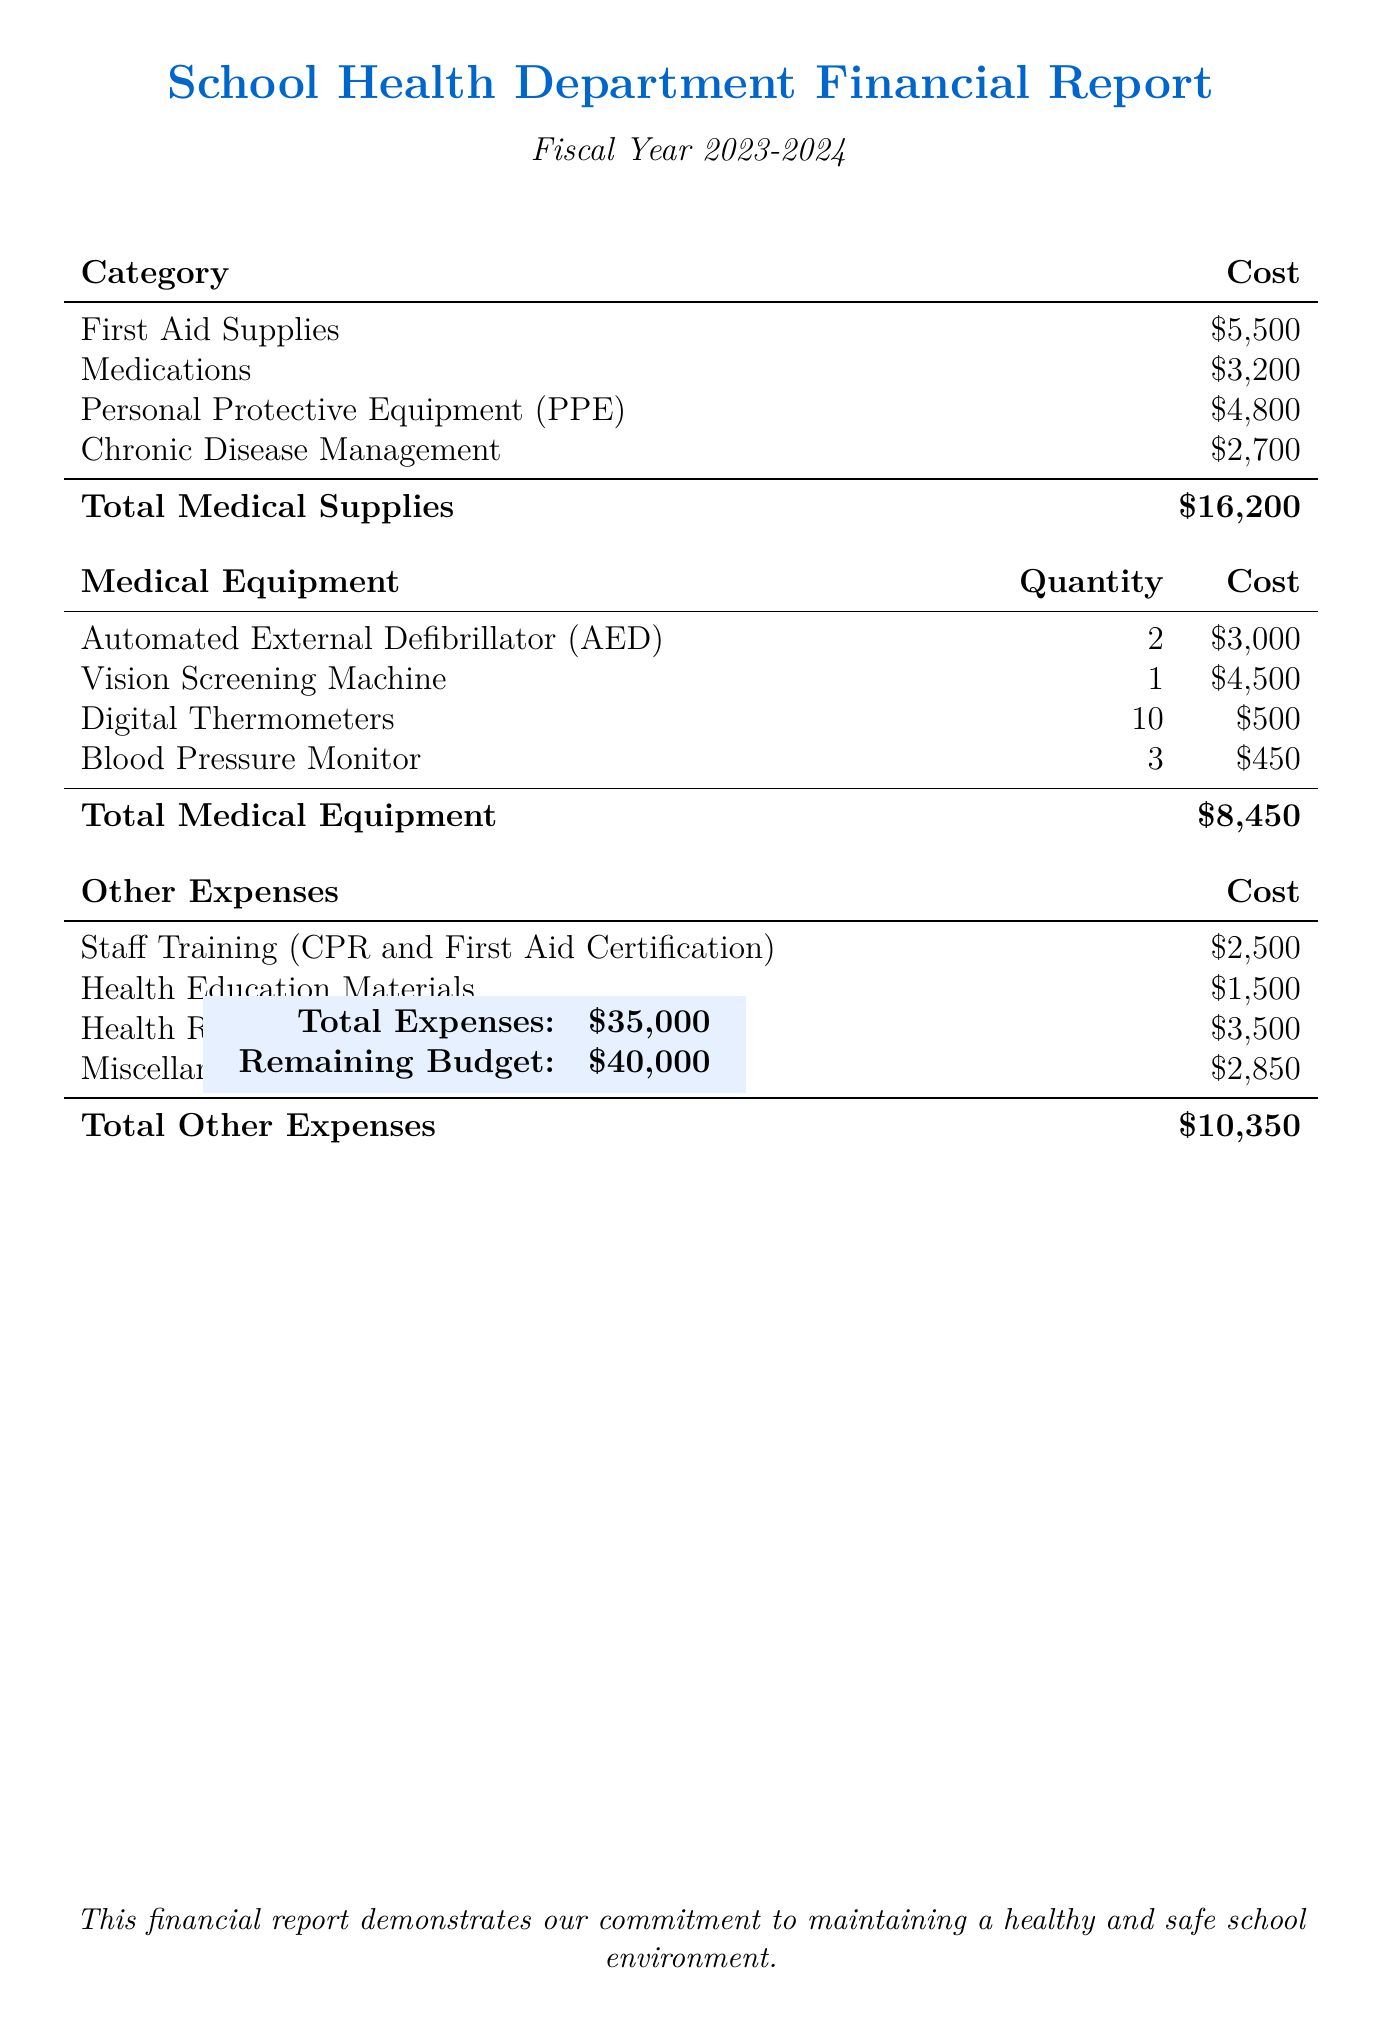what is the total budget allocation? The total budget allocation is explicitly stated in the document as $75,000.
Answer: $75,000 how much is allocated for first aid supplies? The cost of first aid supplies is listed under medical supplies, totaling $5,500.
Answer: $5,500 how many digital thermometers are included in the medical equipment costs? The document specifies that there are 10 digital thermometers included in the medical equipment costs.
Answer: 10 what is the cost of staff training? The cost for staff training is detailed in the document as $2,500.
Answer: $2,500 what are the total expenses for the health department? The total expenses are calculated and presented as $35,000 in the report.
Answer: $35,000 how much is left in the budget after expenses? The remaining budget is provided as $40,000, which is the total allocation minus total expenses.
Answer: $40,000 how much funding is dedicated to health education materials? The document indicates that funding for health education materials amounts to $1,500.
Answer: $1,500 what category does personal protective equipment fall under? Personal protective equipment is classified under medical supplies in the budget breakdown.
Answer: Medical Supplies what is the description of the miscellaneous expenses? Miscellaneous expenses are described in the document as maintenance and unexpected health-related costs.
Answer: Maintenance, unexpected health-related costs 